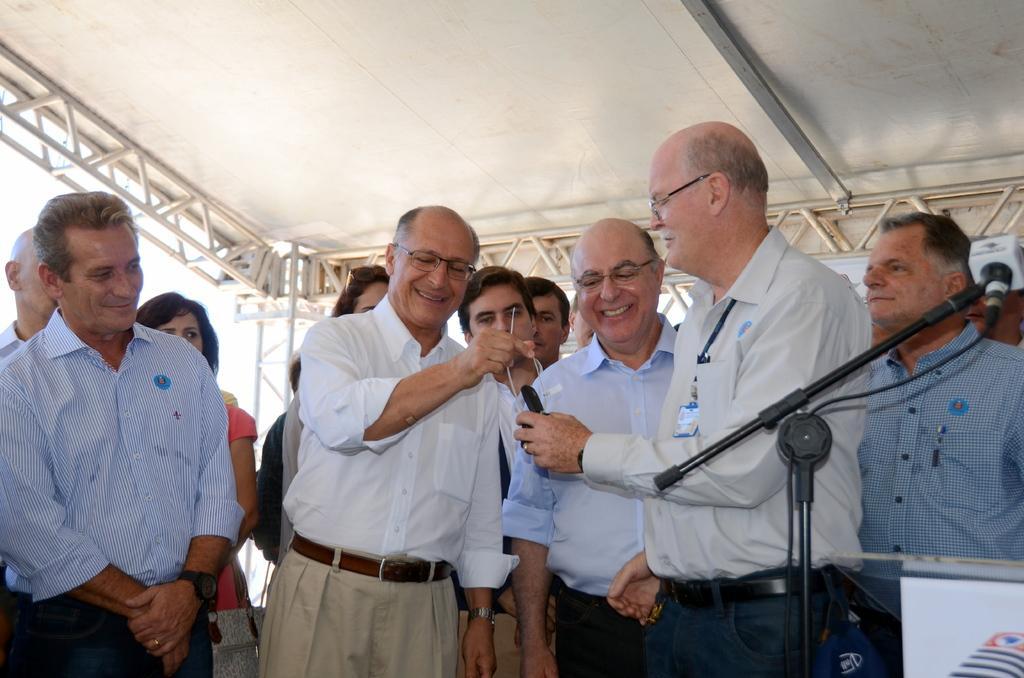Describe this image in one or two sentences. In this picture I can see group of people standing, two persons holding the objects, there is a mike with a mike stand, this is looking like a podium or a table, and in the background there is lighting truss. 